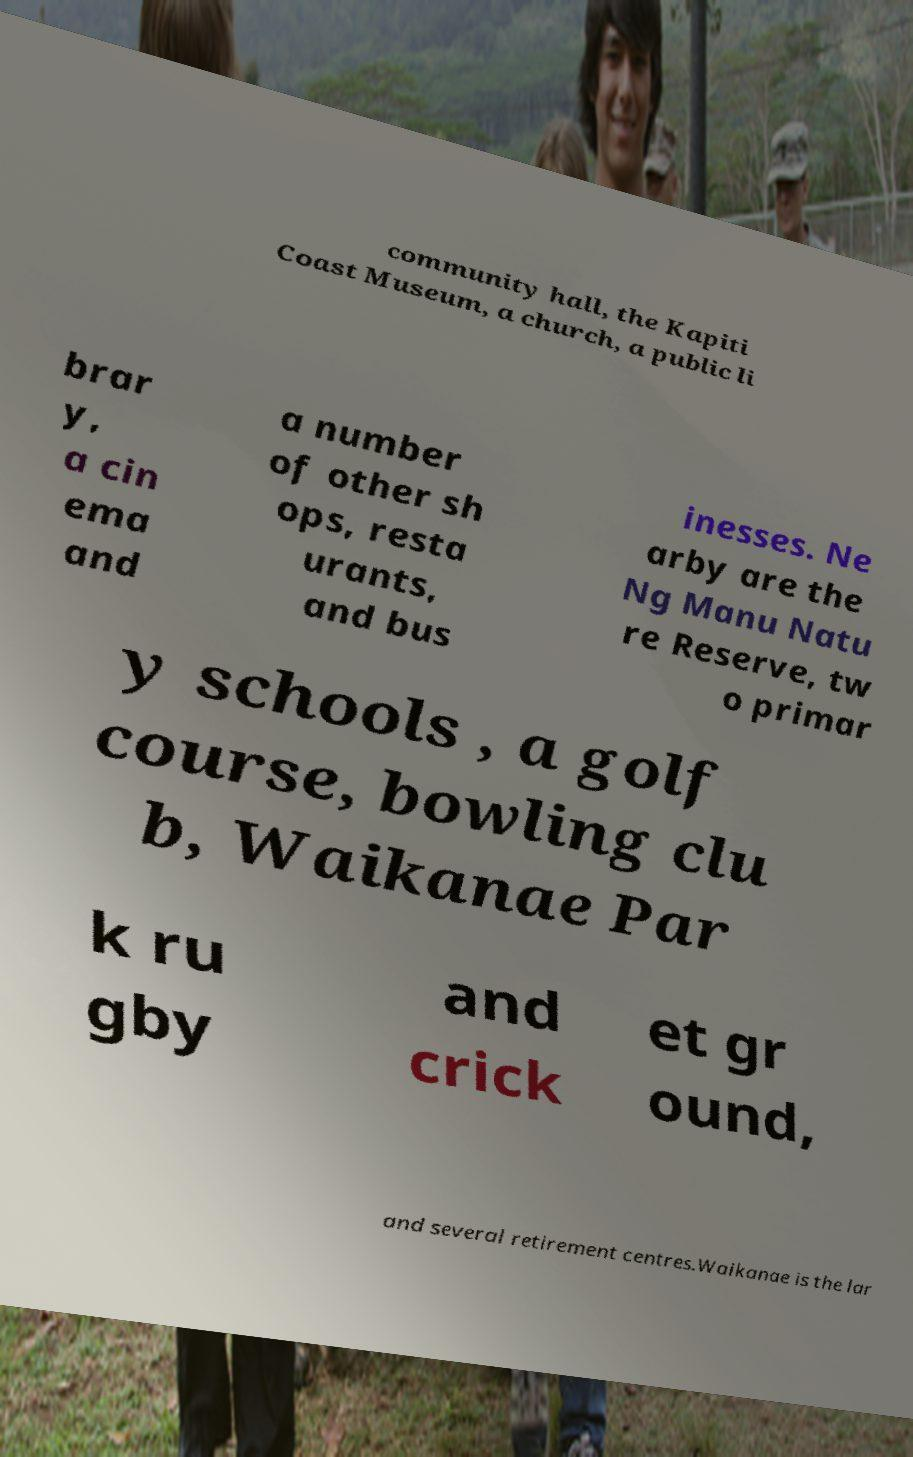Could you extract and type out the text from this image? community hall, the Kapiti Coast Museum, a church, a public li brar y, a cin ema and a number of other sh ops, resta urants, and bus inesses. Ne arby are the Ng Manu Natu re Reserve, tw o primar y schools , a golf course, bowling clu b, Waikanae Par k ru gby and crick et gr ound, and several retirement centres.Waikanae is the lar 